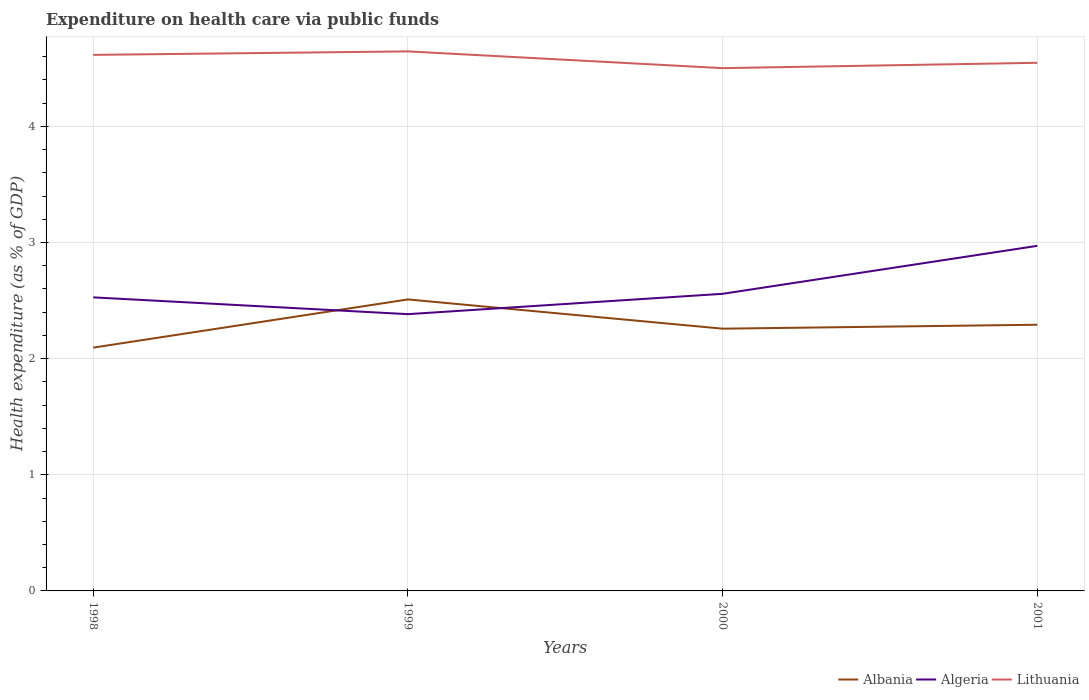Does the line corresponding to Lithuania intersect with the line corresponding to Albania?
Your answer should be compact. No. Is the number of lines equal to the number of legend labels?
Keep it short and to the point. Yes. Across all years, what is the maximum expenditure made on health care in Lithuania?
Your answer should be compact. 4.5. In which year was the expenditure made on health care in Lithuania maximum?
Your answer should be compact. 2000. What is the total expenditure made on health care in Albania in the graph?
Provide a succinct answer. -0.16. What is the difference between the highest and the second highest expenditure made on health care in Algeria?
Give a very brief answer. 0.59. Is the expenditure made on health care in Algeria strictly greater than the expenditure made on health care in Lithuania over the years?
Ensure brevity in your answer.  Yes. How many lines are there?
Your answer should be compact. 3. How many years are there in the graph?
Provide a short and direct response. 4. What is the difference between two consecutive major ticks on the Y-axis?
Offer a terse response. 1. Are the values on the major ticks of Y-axis written in scientific E-notation?
Provide a short and direct response. No. Where does the legend appear in the graph?
Your answer should be very brief. Bottom right. How many legend labels are there?
Offer a terse response. 3. How are the legend labels stacked?
Your answer should be compact. Horizontal. What is the title of the graph?
Give a very brief answer. Expenditure on health care via public funds. Does "Turkmenistan" appear as one of the legend labels in the graph?
Provide a succinct answer. No. What is the label or title of the X-axis?
Your answer should be compact. Years. What is the label or title of the Y-axis?
Keep it short and to the point. Health expenditure (as % of GDP). What is the Health expenditure (as % of GDP) in Albania in 1998?
Offer a terse response. 2.1. What is the Health expenditure (as % of GDP) in Algeria in 1998?
Your answer should be compact. 2.53. What is the Health expenditure (as % of GDP) in Lithuania in 1998?
Give a very brief answer. 4.62. What is the Health expenditure (as % of GDP) of Albania in 1999?
Offer a very short reply. 2.51. What is the Health expenditure (as % of GDP) of Algeria in 1999?
Keep it short and to the point. 2.38. What is the Health expenditure (as % of GDP) of Lithuania in 1999?
Keep it short and to the point. 4.65. What is the Health expenditure (as % of GDP) in Albania in 2000?
Keep it short and to the point. 2.26. What is the Health expenditure (as % of GDP) in Algeria in 2000?
Your answer should be very brief. 2.56. What is the Health expenditure (as % of GDP) of Lithuania in 2000?
Keep it short and to the point. 4.5. What is the Health expenditure (as % of GDP) of Albania in 2001?
Your answer should be compact. 2.29. What is the Health expenditure (as % of GDP) in Algeria in 2001?
Your answer should be compact. 2.97. What is the Health expenditure (as % of GDP) in Lithuania in 2001?
Offer a very short reply. 4.55. Across all years, what is the maximum Health expenditure (as % of GDP) of Albania?
Your answer should be compact. 2.51. Across all years, what is the maximum Health expenditure (as % of GDP) in Algeria?
Your answer should be compact. 2.97. Across all years, what is the maximum Health expenditure (as % of GDP) in Lithuania?
Ensure brevity in your answer.  4.65. Across all years, what is the minimum Health expenditure (as % of GDP) in Albania?
Ensure brevity in your answer.  2.1. Across all years, what is the minimum Health expenditure (as % of GDP) in Algeria?
Your answer should be very brief. 2.38. Across all years, what is the minimum Health expenditure (as % of GDP) of Lithuania?
Offer a very short reply. 4.5. What is the total Health expenditure (as % of GDP) of Albania in the graph?
Offer a terse response. 9.16. What is the total Health expenditure (as % of GDP) in Algeria in the graph?
Give a very brief answer. 10.44. What is the total Health expenditure (as % of GDP) in Lithuania in the graph?
Offer a terse response. 18.31. What is the difference between the Health expenditure (as % of GDP) of Albania in 1998 and that in 1999?
Make the answer very short. -0.41. What is the difference between the Health expenditure (as % of GDP) of Algeria in 1998 and that in 1999?
Offer a terse response. 0.14. What is the difference between the Health expenditure (as % of GDP) of Lithuania in 1998 and that in 1999?
Provide a succinct answer. -0.03. What is the difference between the Health expenditure (as % of GDP) in Albania in 1998 and that in 2000?
Your response must be concise. -0.16. What is the difference between the Health expenditure (as % of GDP) of Algeria in 1998 and that in 2000?
Provide a succinct answer. -0.03. What is the difference between the Health expenditure (as % of GDP) in Lithuania in 1998 and that in 2000?
Keep it short and to the point. 0.11. What is the difference between the Health expenditure (as % of GDP) of Albania in 1998 and that in 2001?
Make the answer very short. -0.2. What is the difference between the Health expenditure (as % of GDP) of Algeria in 1998 and that in 2001?
Provide a short and direct response. -0.44. What is the difference between the Health expenditure (as % of GDP) of Lithuania in 1998 and that in 2001?
Keep it short and to the point. 0.07. What is the difference between the Health expenditure (as % of GDP) in Albania in 1999 and that in 2000?
Your response must be concise. 0.25. What is the difference between the Health expenditure (as % of GDP) in Algeria in 1999 and that in 2000?
Give a very brief answer. -0.18. What is the difference between the Health expenditure (as % of GDP) in Lithuania in 1999 and that in 2000?
Ensure brevity in your answer.  0.14. What is the difference between the Health expenditure (as % of GDP) in Albania in 1999 and that in 2001?
Offer a very short reply. 0.22. What is the difference between the Health expenditure (as % of GDP) of Algeria in 1999 and that in 2001?
Offer a terse response. -0.59. What is the difference between the Health expenditure (as % of GDP) in Lithuania in 1999 and that in 2001?
Offer a terse response. 0.1. What is the difference between the Health expenditure (as % of GDP) of Albania in 2000 and that in 2001?
Keep it short and to the point. -0.03. What is the difference between the Health expenditure (as % of GDP) of Algeria in 2000 and that in 2001?
Give a very brief answer. -0.41. What is the difference between the Health expenditure (as % of GDP) of Lithuania in 2000 and that in 2001?
Your response must be concise. -0.05. What is the difference between the Health expenditure (as % of GDP) of Albania in 1998 and the Health expenditure (as % of GDP) of Algeria in 1999?
Provide a succinct answer. -0.29. What is the difference between the Health expenditure (as % of GDP) of Albania in 1998 and the Health expenditure (as % of GDP) of Lithuania in 1999?
Offer a very short reply. -2.55. What is the difference between the Health expenditure (as % of GDP) of Algeria in 1998 and the Health expenditure (as % of GDP) of Lithuania in 1999?
Your answer should be compact. -2.12. What is the difference between the Health expenditure (as % of GDP) in Albania in 1998 and the Health expenditure (as % of GDP) in Algeria in 2000?
Keep it short and to the point. -0.46. What is the difference between the Health expenditure (as % of GDP) in Albania in 1998 and the Health expenditure (as % of GDP) in Lithuania in 2000?
Provide a short and direct response. -2.41. What is the difference between the Health expenditure (as % of GDP) of Algeria in 1998 and the Health expenditure (as % of GDP) of Lithuania in 2000?
Offer a very short reply. -1.97. What is the difference between the Health expenditure (as % of GDP) in Albania in 1998 and the Health expenditure (as % of GDP) in Algeria in 2001?
Offer a terse response. -0.88. What is the difference between the Health expenditure (as % of GDP) in Albania in 1998 and the Health expenditure (as % of GDP) in Lithuania in 2001?
Offer a terse response. -2.45. What is the difference between the Health expenditure (as % of GDP) of Algeria in 1998 and the Health expenditure (as % of GDP) of Lithuania in 2001?
Offer a terse response. -2.02. What is the difference between the Health expenditure (as % of GDP) of Albania in 1999 and the Health expenditure (as % of GDP) of Algeria in 2000?
Make the answer very short. -0.05. What is the difference between the Health expenditure (as % of GDP) of Albania in 1999 and the Health expenditure (as % of GDP) of Lithuania in 2000?
Offer a very short reply. -1.99. What is the difference between the Health expenditure (as % of GDP) in Algeria in 1999 and the Health expenditure (as % of GDP) in Lithuania in 2000?
Keep it short and to the point. -2.12. What is the difference between the Health expenditure (as % of GDP) in Albania in 1999 and the Health expenditure (as % of GDP) in Algeria in 2001?
Provide a succinct answer. -0.46. What is the difference between the Health expenditure (as % of GDP) of Albania in 1999 and the Health expenditure (as % of GDP) of Lithuania in 2001?
Your response must be concise. -2.04. What is the difference between the Health expenditure (as % of GDP) of Algeria in 1999 and the Health expenditure (as % of GDP) of Lithuania in 2001?
Make the answer very short. -2.16. What is the difference between the Health expenditure (as % of GDP) of Albania in 2000 and the Health expenditure (as % of GDP) of Algeria in 2001?
Your answer should be compact. -0.71. What is the difference between the Health expenditure (as % of GDP) in Albania in 2000 and the Health expenditure (as % of GDP) in Lithuania in 2001?
Keep it short and to the point. -2.29. What is the difference between the Health expenditure (as % of GDP) of Algeria in 2000 and the Health expenditure (as % of GDP) of Lithuania in 2001?
Your answer should be very brief. -1.99. What is the average Health expenditure (as % of GDP) in Albania per year?
Provide a succinct answer. 2.29. What is the average Health expenditure (as % of GDP) in Algeria per year?
Your response must be concise. 2.61. What is the average Health expenditure (as % of GDP) in Lithuania per year?
Keep it short and to the point. 4.58. In the year 1998, what is the difference between the Health expenditure (as % of GDP) in Albania and Health expenditure (as % of GDP) in Algeria?
Provide a short and direct response. -0.43. In the year 1998, what is the difference between the Health expenditure (as % of GDP) of Albania and Health expenditure (as % of GDP) of Lithuania?
Offer a terse response. -2.52. In the year 1998, what is the difference between the Health expenditure (as % of GDP) in Algeria and Health expenditure (as % of GDP) in Lithuania?
Keep it short and to the point. -2.09. In the year 1999, what is the difference between the Health expenditure (as % of GDP) of Albania and Health expenditure (as % of GDP) of Algeria?
Keep it short and to the point. 0.13. In the year 1999, what is the difference between the Health expenditure (as % of GDP) in Albania and Health expenditure (as % of GDP) in Lithuania?
Provide a short and direct response. -2.14. In the year 1999, what is the difference between the Health expenditure (as % of GDP) in Algeria and Health expenditure (as % of GDP) in Lithuania?
Provide a succinct answer. -2.26. In the year 2000, what is the difference between the Health expenditure (as % of GDP) of Albania and Health expenditure (as % of GDP) of Algeria?
Provide a succinct answer. -0.3. In the year 2000, what is the difference between the Health expenditure (as % of GDP) of Albania and Health expenditure (as % of GDP) of Lithuania?
Make the answer very short. -2.24. In the year 2000, what is the difference between the Health expenditure (as % of GDP) of Algeria and Health expenditure (as % of GDP) of Lithuania?
Ensure brevity in your answer.  -1.94. In the year 2001, what is the difference between the Health expenditure (as % of GDP) of Albania and Health expenditure (as % of GDP) of Algeria?
Give a very brief answer. -0.68. In the year 2001, what is the difference between the Health expenditure (as % of GDP) of Albania and Health expenditure (as % of GDP) of Lithuania?
Your answer should be compact. -2.26. In the year 2001, what is the difference between the Health expenditure (as % of GDP) in Algeria and Health expenditure (as % of GDP) in Lithuania?
Your response must be concise. -1.58. What is the ratio of the Health expenditure (as % of GDP) in Albania in 1998 to that in 1999?
Give a very brief answer. 0.83. What is the ratio of the Health expenditure (as % of GDP) in Algeria in 1998 to that in 1999?
Provide a succinct answer. 1.06. What is the ratio of the Health expenditure (as % of GDP) in Lithuania in 1998 to that in 1999?
Your answer should be compact. 0.99. What is the ratio of the Health expenditure (as % of GDP) in Albania in 1998 to that in 2000?
Make the answer very short. 0.93. What is the ratio of the Health expenditure (as % of GDP) of Algeria in 1998 to that in 2000?
Your answer should be very brief. 0.99. What is the ratio of the Health expenditure (as % of GDP) in Lithuania in 1998 to that in 2000?
Give a very brief answer. 1.03. What is the ratio of the Health expenditure (as % of GDP) of Albania in 1998 to that in 2001?
Keep it short and to the point. 0.91. What is the ratio of the Health expenditure (as % of GDP) in Algeria in 1998 to that in 2001?
Give a very brief answer. 0.85. What is the ratio of the Health expenditure (as % of GDP) in Lithuania in 1998 to that in 2001?
Give a very brief answer. 1.01. What is the ratio of the Health expenditure (as % of GDP) in Albania in 1999 to that in 2000?
Provide a short and direct response. 1.11. What is the ratio of the Health expenditure (as % of GDP) of Algeria in 1999 to that in 2000?
Ensure brevity in your answer.  0.93. What is the ratio of the Health expenditure (as % of GDP) in Lithuania in 1999 to that in 2000?
Your answer should be very brief. 1.03. What is the ratio of the Health expenditure (as % of GDP) in Albania in 1999 to that in 2001?
Provide a succinct answer. 1.1. What is the ratio of the Health expenditure (as % of GDP) in Algeria in 1999 to that in 2001?
Your answer should be very brief. 0.8. What is the ratio of the Health expenditure (as % of GDP) in Lithuania in 1999 to that in 2001?
Make the answer very short. 1.02. What is the ratio of the Health expenditure (as % of GDP) in Algeria in 2000 to that in 2001?
Keep it short and to the point. 0.86. What is the ratio of the Health expenditure (as % of GDP) of Lithuania in 2000 to that in 2001?
Your response must be concise. 0.99. What is the difference between the highest and the second highest Health expenditure (as % of GDP) in Albania?
Offer a terse response. 0.22. What is the difference between the highest and the second highest Health expenditure (as % of GDP) of Algeria?
Your answer should be very brief. 0.41. What is the difference between the highest and the second highest Health expenditure (as % of GDP) in Lithuania?
Keep it short and to the point. 0.03. What is the difference between the highest and the lowest Health expenditure (as % of GDP) of Albania?
Your answer should be very brief. 0.41. What is the difference between the highest and the lowest Health expenditure (as % of GDP) of Algeria?
Provide a short and direct response. 0.59. What is the difference between the highest and the lowest Health expenditure (as % of GDP) of Lithuania?
Offer a very short reply. 0.14. 